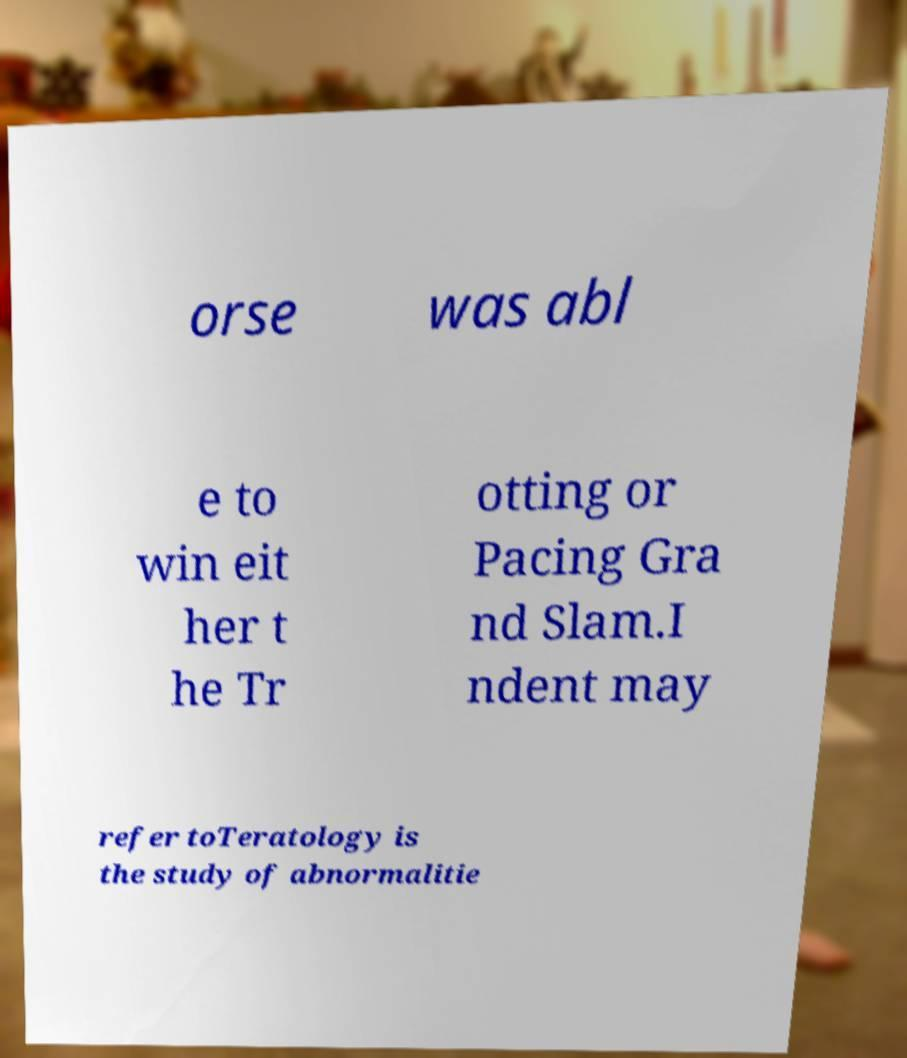Could you extract and type out the text from this image? orse was abl e to win eit her t he Tr otting or Pacing Gra nd Slam.I ndent may refer toTeratology is the study of abnormalitie 